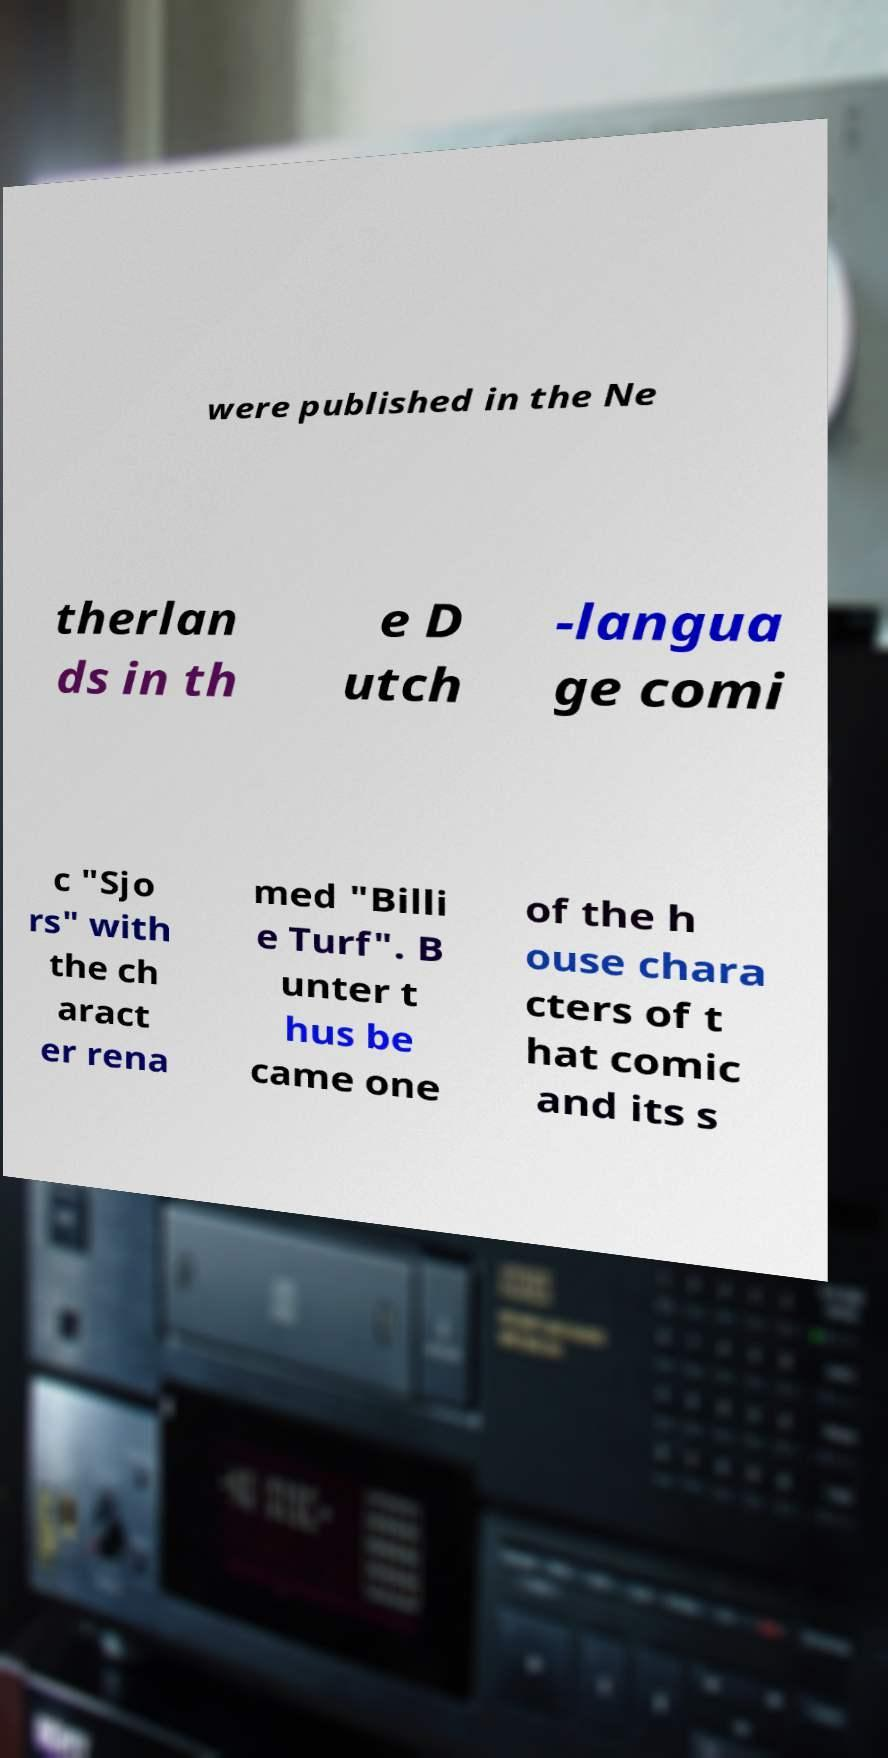For documentation purposes, I need the text within this image transcribed. Could you provide that? were published in the Ne therlan ds in th e D utch -langua ge comi c "Sjo rs" with the ch aract er rena med "Billi e Turf". B unter t hus be came one of the h ouse chara cters of t hat comic and its s 